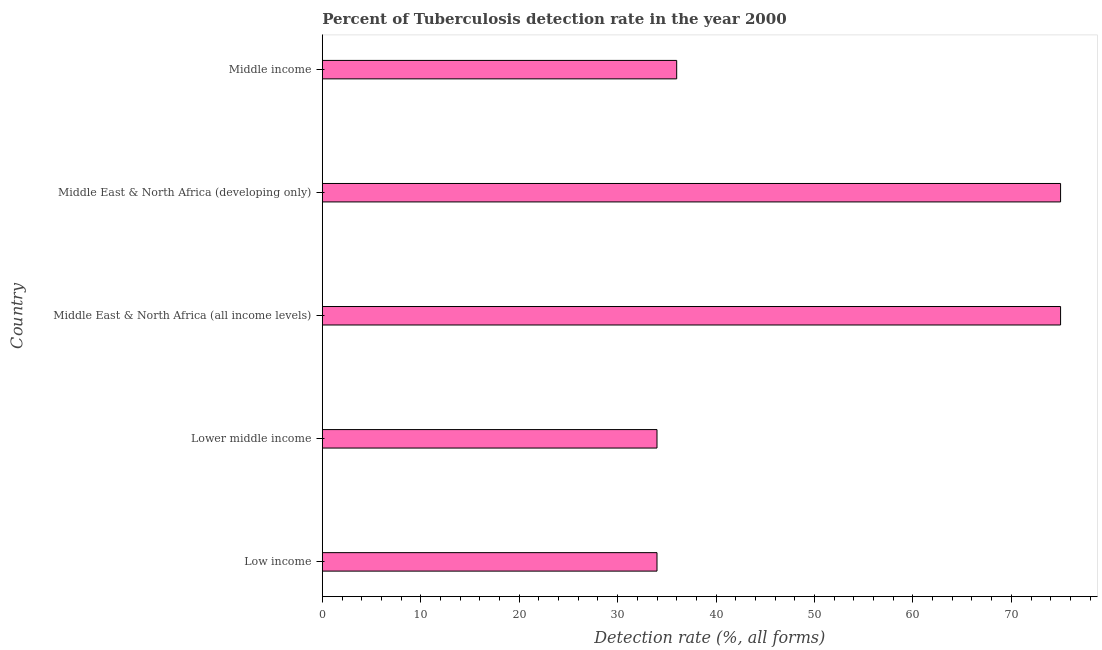Does the graph contain grids?
Provide a succinct answer. No. What is the title of the graph?
Ensure brevity in your answer.  Percent of Tuberculosis detection rate in the year 2000. What is the label or title of the X-axis?
Your response must be concise. Detection rate (%, all forms). Across all countries, what is the minimum detection rate of tuberculosis?
Keep it short and to the point. 34. In which country was the detection rate of tuberculosis maximum?
Provide a short and direct response. Middle East & North Africa (all income levels). In which country was the detection rate of tuberculosis minimum?
Provide a short and direct response. Low income. What is the sum of the detection rate of tuberculosis?
Provide a succinct answer. 254. What is the average detection rate of tuberculosis per country?
Give a very brief answer. 50.8. What is the median detection rate of tuberculosis?
Give a very brief answer. 36. In how many countries, is the detection rate of tuberculosis greater than 16 %?
Offer a very short reply. 5. What is the ratio of the detection rate of tuberculosis in Middle East & North Africa (developing only) to that in Middle income?
Offer a very short reply. 2.08. Are all the bars in the graph horizontal?
Give a very brief answer. Yes. What is the Detection rate (%, all forms) of Low income?
Your answer should be compact. 34. What is the Detection rate (%, all forms) of Middle East & North Africa (all income levels)?
Your response must be concise. 75. What is the Detection rate (%, all forms) in Middle East & North Africa (developing only)?
Make the answer very short. 75. What is the Detection rate (%, all forms) in Middle income?
Provide a short and direct response. 36. What is the difference between the Detection rate (%, all forms) in Low income and Lower middle income?
Offer a very short reply. 0. What is the difference between the Detection rate (%, all forms) in Low income and Middle East & North Africa (all income levels)?
Ensure brevity in your answer.  -41. What is the difference between the Detection rate (%, all forms) in Low income and Middle East & North Africa (developing only)?
Provide a succinct answer. -41. What is the difference between the Detection rate (%, all forms) in Low income and Middle income?
Ensure brevity in your answer.  -2. What is the difference between the Detection rate (%, all forms) in Lower middle income and Middle East & North Africa (all income levels)?
Offer a very short reply. -41. What is the difference between the Detection rate (%, all forms) in Lower middle income and Middle East & North Africa (developing only)?
Keep it short and to the point. -41. What is the difference between the Detection rate (%, all forms) in Middle East & North Africa (all income levels) and Middle income?
Offer a terse response. 39. What is the ratio of the Detection rate (%, all forms) in Low income to that in Middle East & North Africa (all income levels)?
Provide a short and direct response. 0.45. What is the ratio of the Detection rate (%, all forms) in Low income to that in Middle East & North Africa (developing only)?
Your response must be concise. 0.45. What is the ratio of the Detection rate (%, all forms) in Low income to that in Middle income?
Give a very brief answer. 0.94. What is the ratio of the Detection rate (%, all forms) in Lower middle income to that in Middle East & North Africa (all income levels)?
Offer a terse response. 0.45. What is the ratio of the Detection rate (%, all forms) in Lower middle income to that in Middle East & North Africa (developing only)?
Provide a succinct answer. 0.45. What is the ratio of the Detection rate (%, all forms) in Lower middle income to that in Middle income?
Make the answer very short. 0.94. What is the ratio of the Detection rate (%, all forms) in Middle East & North Africa (all income levels) to that in Middle East & North Africa (developing only)?
Your answer should be compact. 1. What is the ratio of the Detection rate (%, all forms) in Middle East & North Africa (all income levels) to that in Middle income?
Your response must be concise. 2.08. What is the ratio of the Detection rate (%, all forms) in Middle East & North Africa (developing only) to that in Middle income?
Your response must be concise. 2.08. 